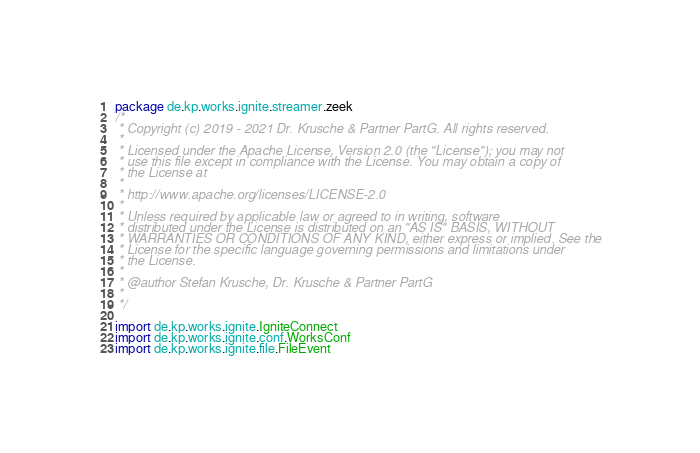<code> <loc_0><loc_0><loc_500><loc_500><_Scala_>package de.kp.works.ignite.streamer.zeek
/*
 * Copyright (c) 2019 - 2021 Dr. Krusche & Partner PartG. All rights reserved.
 *
 * Licensed under the Apache License, Version 2.0 (the "License"); you may not
 * use this file except in compliance with the License. You may obtain a copy of
 * the License at
 *
 * http://www.apache.org/licenses/LICENSE-2.0
 *
 * Unless required by applicable law or agreed to in writing, software
 * distributed under the License is distributed on an "AS IS" BASIS, WITHOUT
 * WARRANTIES OR CONDITIONS OF ANY KIND, either express or implied. See the
 * License for the specific language governing permissions and limitations under
 * the License.
 *
 * @author Stefan Krusche, Dr. Krusche & Partner PartG
 *
 */

import de.kp.works.ignite.IgniteConnect
import de.kp.works.ignite.conf.WorksConf
import de.kp.works.ignite.file.FileEvent</code> 